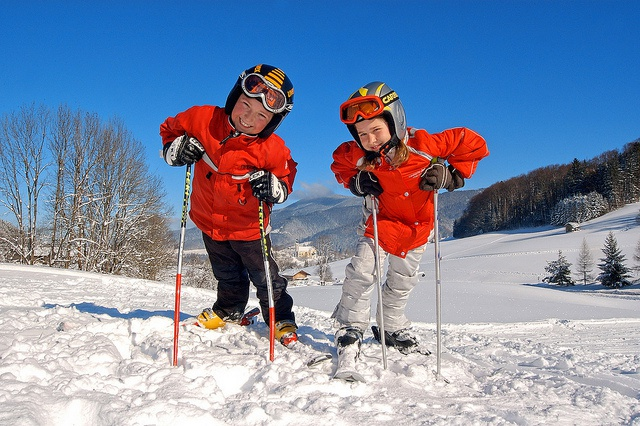Describe the objects in this image and their specific colors. I can see people in blue, red, darkgray, brown, and black tones, people in blue, black, brown, red, and maroon tones, skis in blue, darkgray, lightgray, and gray tones, and skis in blue, lightgray, darkgray, gray, and maroon tones in this image. 